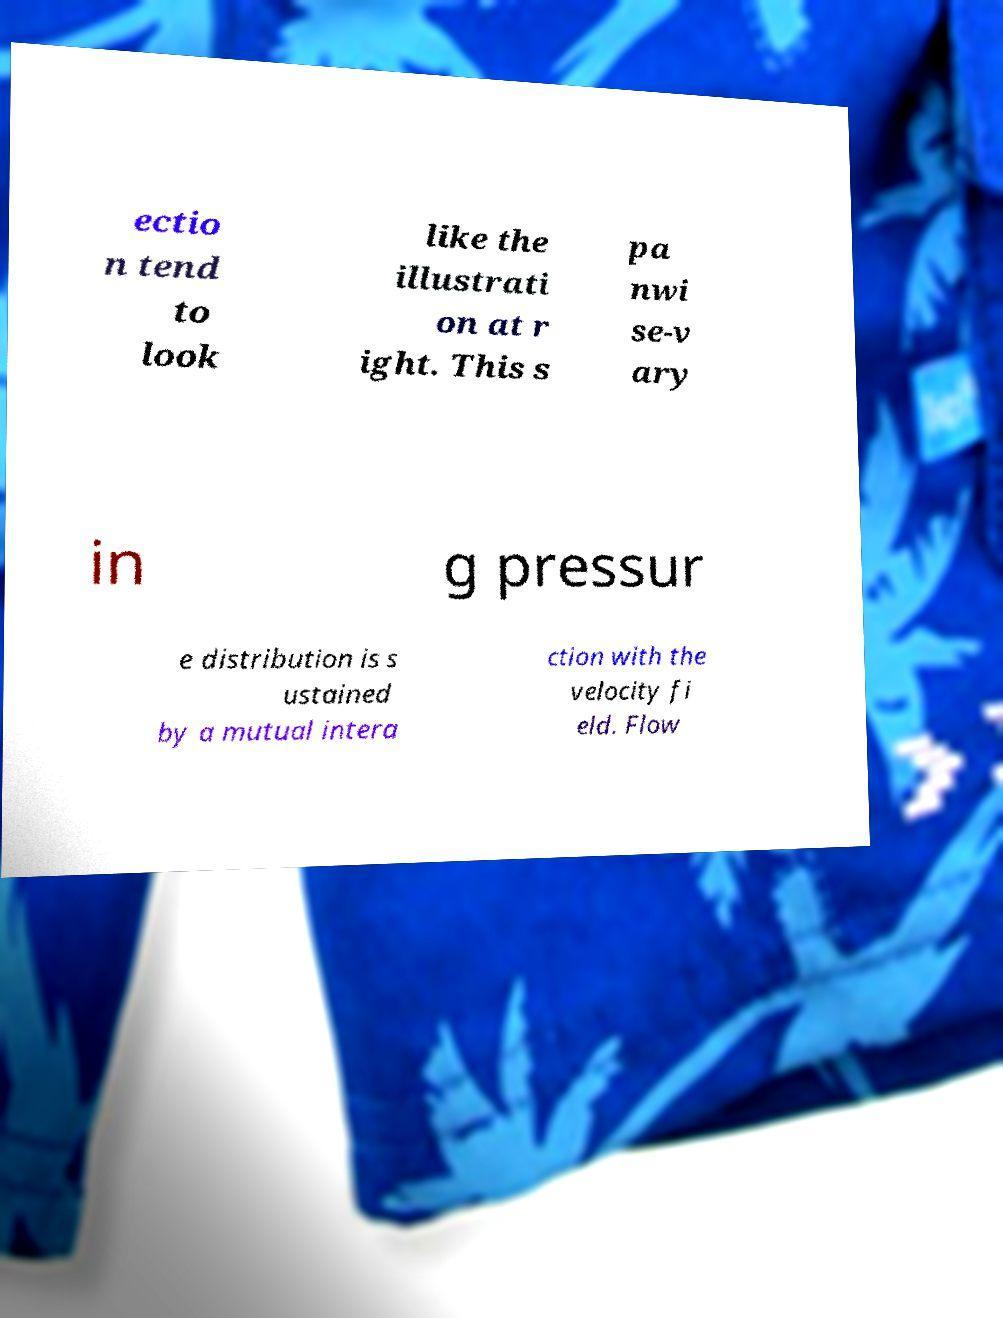Please read and relay the text visible in this image. What does it say? ectio n tend to look like the illustrati on at r ight. This s pa nwi se-v ary in g pressur e distribution is s ustained by a mutual intera ction with the velocity fi eld. Flow 